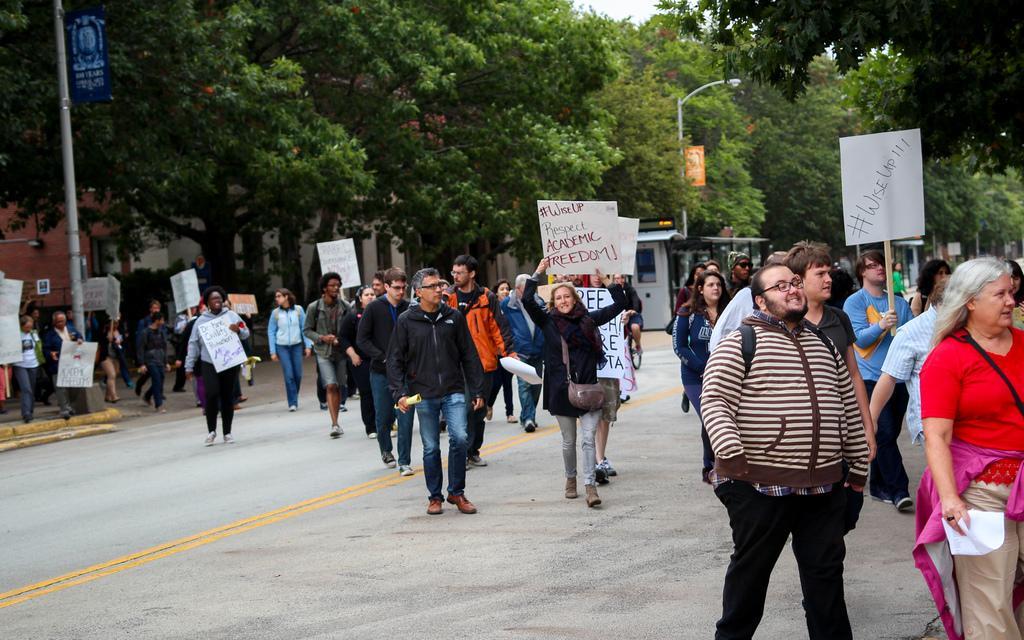How would you summarize this image in a sentence or two? In this picture there are group of persons standing where few among them are holding a white sheet which has something written on it and there are trees,poles and a building in the background. 